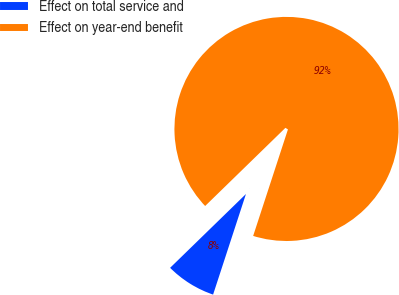Convert chart to OTSL. <chart><loc_0><loc_0><loc_500><loc_500><pie_chart><fcel>Effect on total service and<fcel>Effect on year-end benefit<nl><fcel>7.69%<fcel>92.31%<nl></chart> 